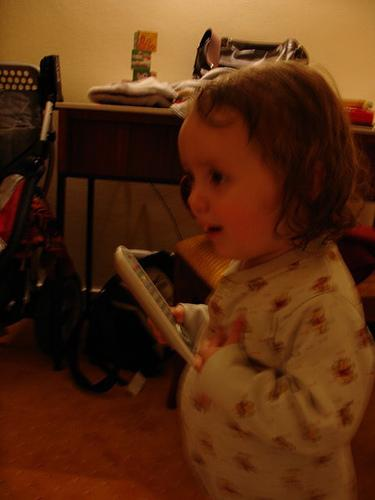Judging by the childs hair what did they just get done with?

Choices:
A) sleeping
B) bath
C) eating
D) fighting bath 